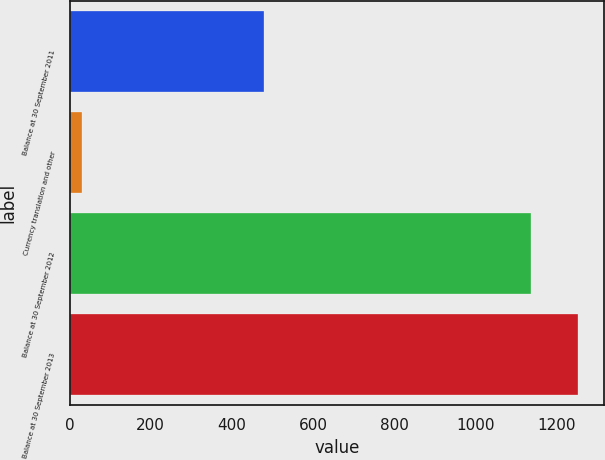Convert chart to OTSL. <chart><loc_0><loc_0><loc_500><loc_500><bar_chart><fcel>Balance at 30 September 2011<fcel>Currency translation and other<fcel>Balance at 30 September 2012<fcel>Balance at 30 September 2013<nl><fcel>479.2<fcel>29.4<fcel>1138.6<fcel>1254.86<nl></chart> 